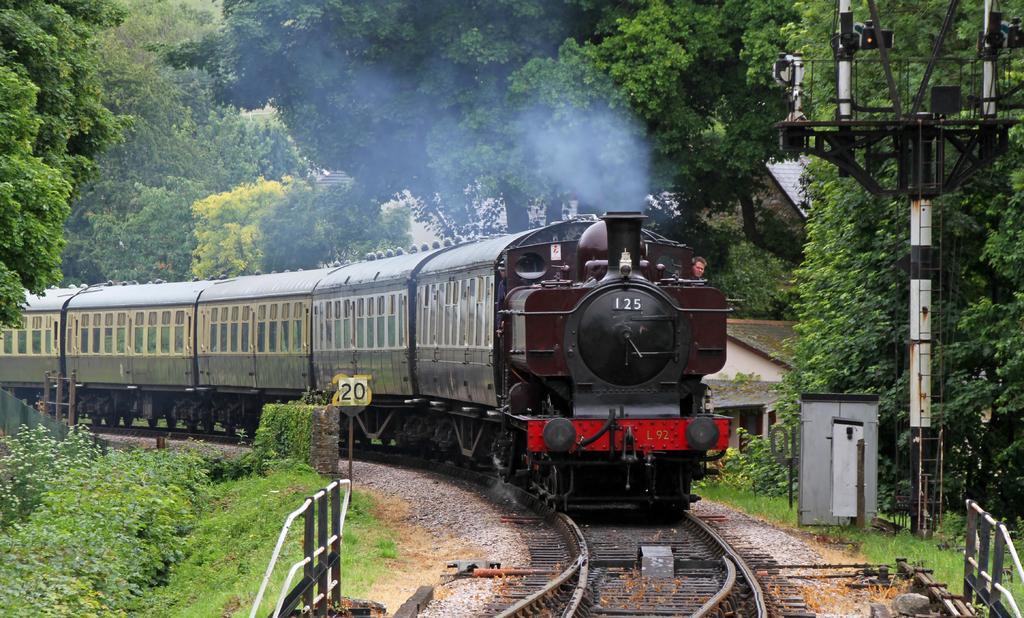Please provide a concise description of this image. In this image, I can see a train on the railway track. On the right side of the image, I can see a pole, metal box, houses and iron grilles. On the left side of the image, I can see a board to a pole and plants. In the background, there are trees. 